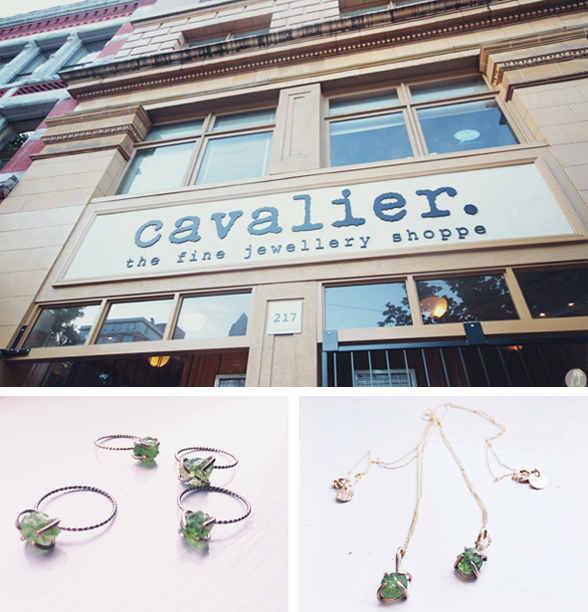What might be the significance of using green gemstones in this collection? Green gemstones are often associated with vitality, growth, and prosperity, making them a compelling choice for jewelry. They can provide a striking visual contrast in a piece and might be used to convey a sense of rejuvenation and natural beauty. This choice could be particularly appealing to consumers drawn to colorful, vibrant jewelry that carries deeper symbolic meaning. Are there specific types of green gemstones that are considered more valuable? Yes, certain green gemstones like emeralds, jade, and tsavorites are highly prized for their color and rarity. Emeralds, for example, are valued for their vibrant green hue and are often more valuable when they are transparent and free of inclusions. The specific type of green gemstone used in Cavalier's collection can significantly influence both its aesthetic appeal and market value. 